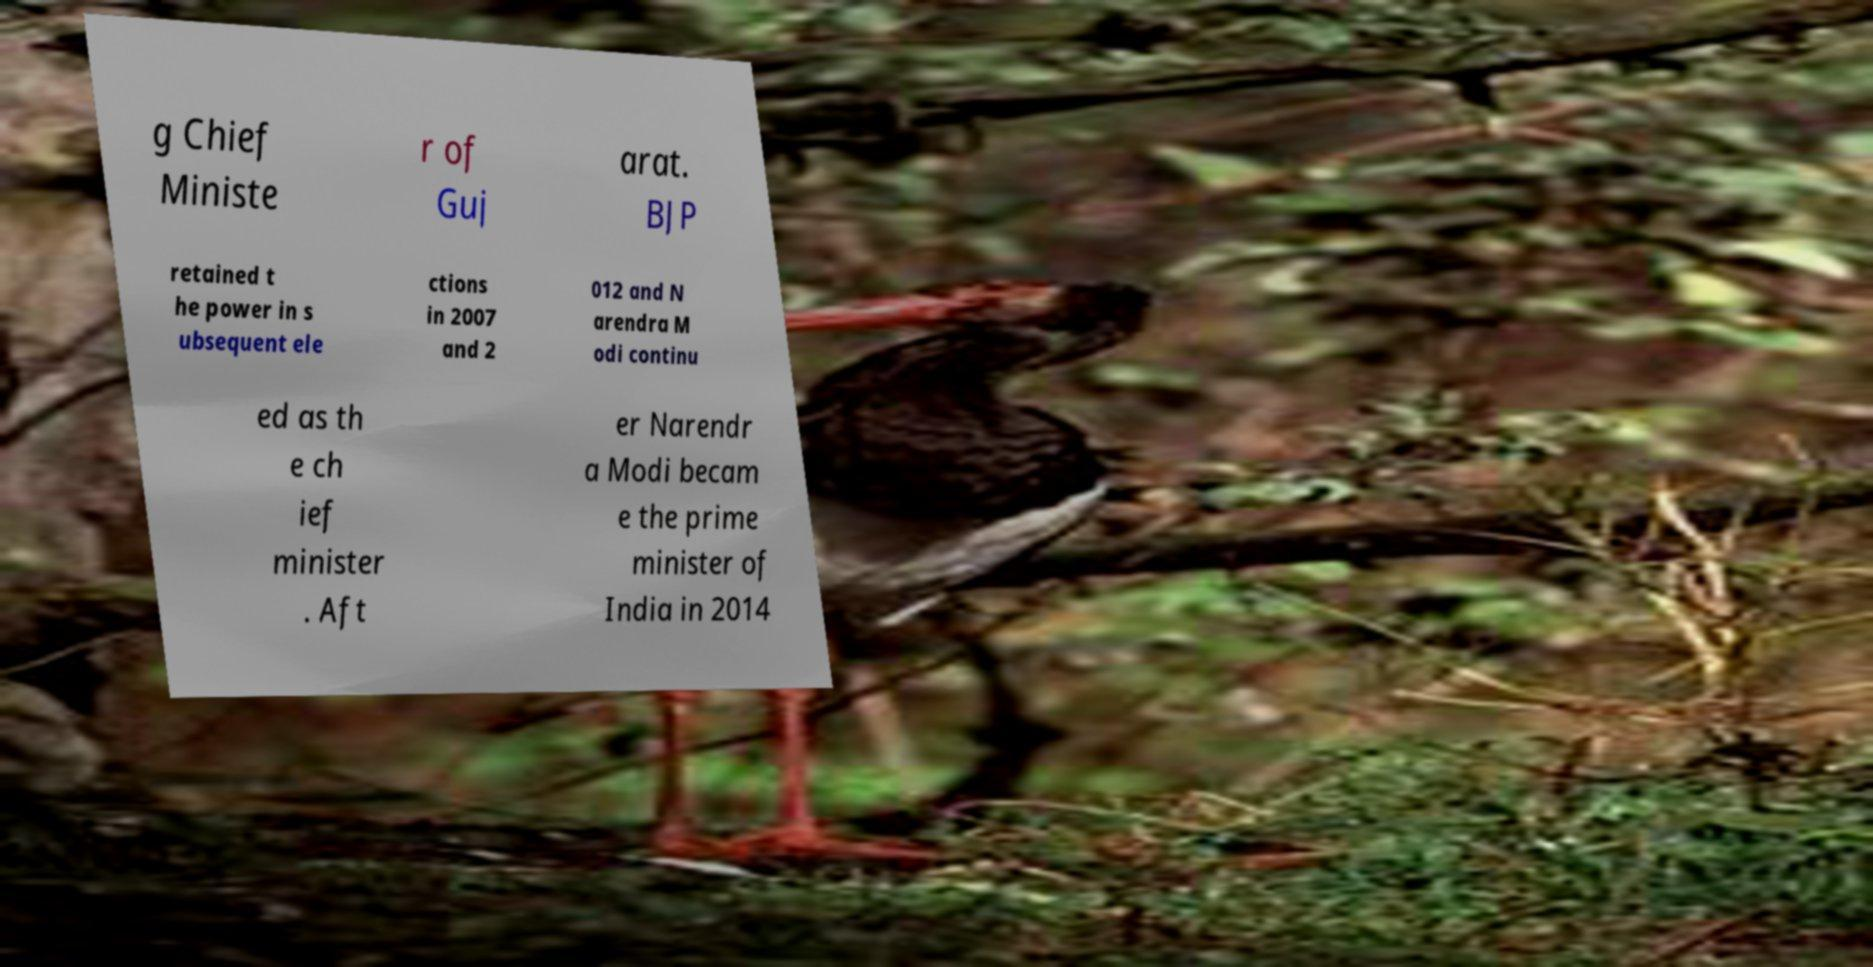Please read and relay the text visible in this image. What does it say? g Chief Ministe r of Guj arat. BJP retained t he power in s ubsequent ele ctions in 2007 and 2 012 and N arendra M odi continu ed as th e ch ief minister . Aft er Narendr a Modi becam e the prime minister of India in 2014 